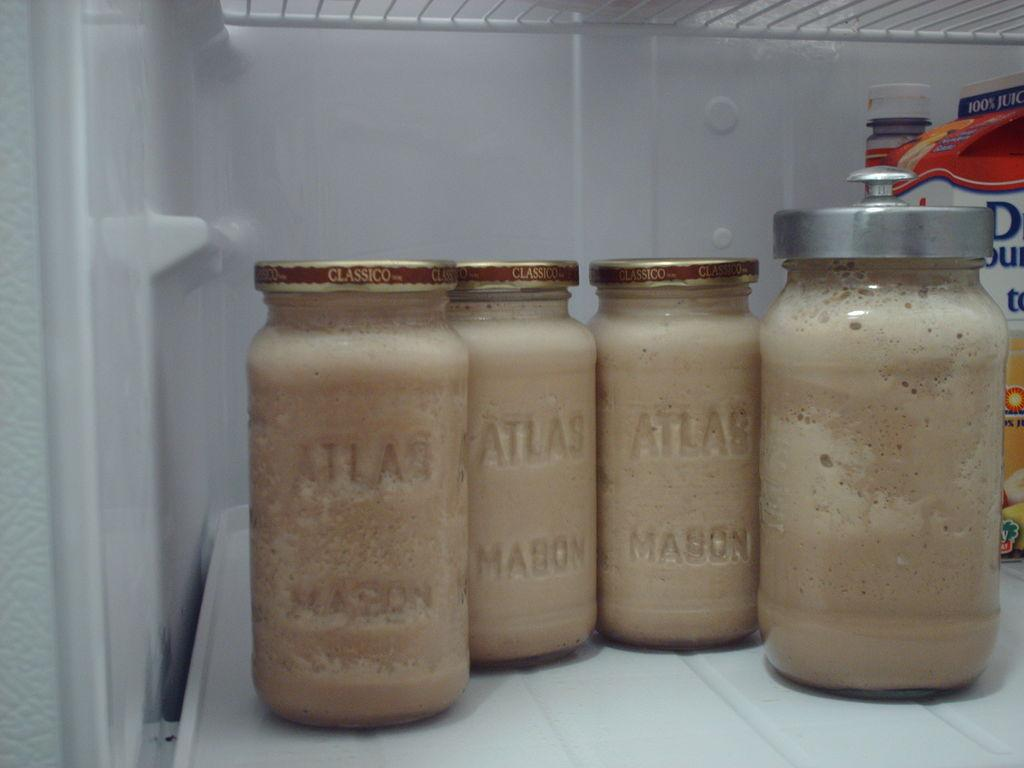What type of containers are visible in the image? There are glass jars in the image. Where are the glass jars located? The glass jars are inside the fridge in the image. What can be found inside the glass jars? The contents of the glass jars are not visible in the image. What type of shelf can be seen in the image? There is no shelf visible in the image. Can you describe the sky in the image? The image does not show the sky; it is focused on the contents of the fridge. 